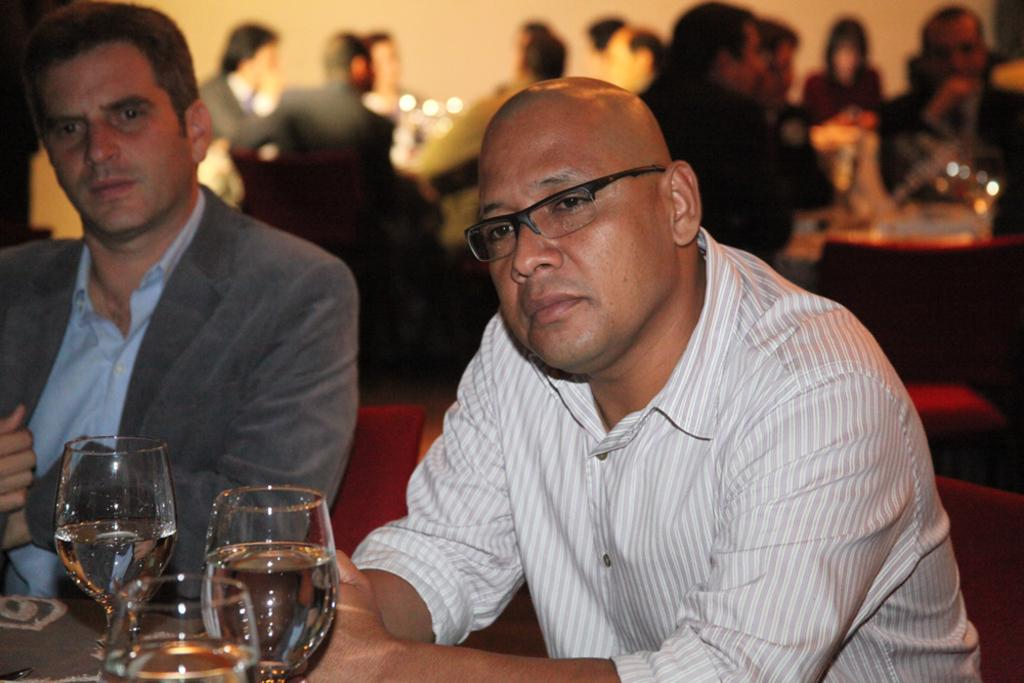How many people are sitting in the image? There are two persons sitting in the image. What is in front of the two persons? There is a table in front of the two persons. What can be seen on the table? There are glasses on the table. Can you describe the people sitting in the background of the image? There are people sitting in the background of the image. What type of mask is the person wearing in the image? There is no person wearing a mask in the image. Is the image a scene from a fictional story? The image does not provide any information about it being a scene from a fictional story. 